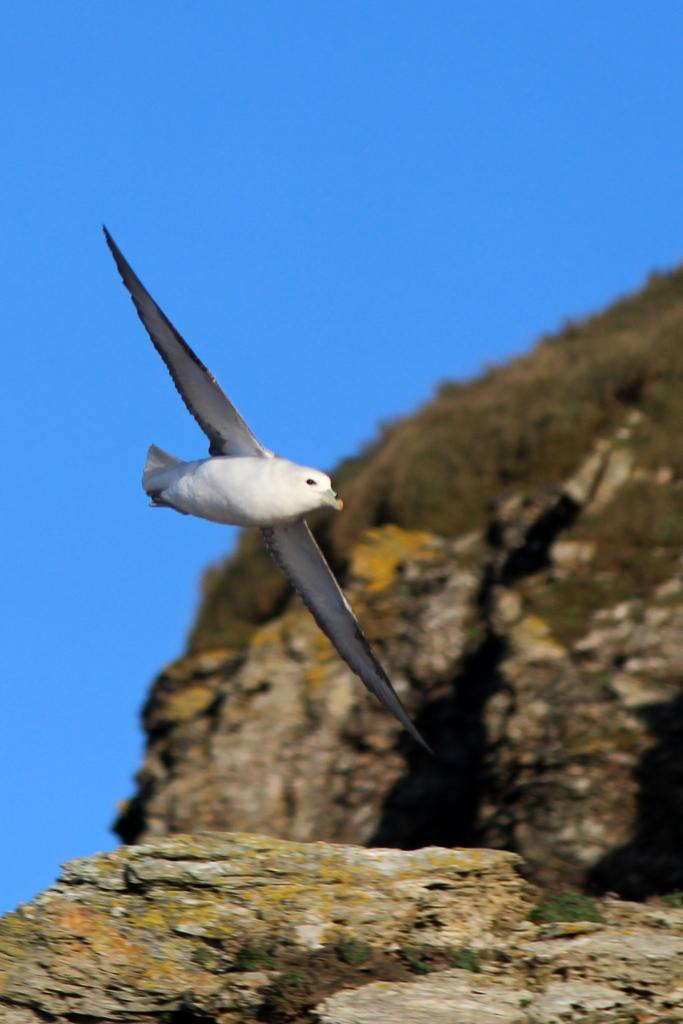What type of animal can be seen in the image? There is a bird in the image. Where is the bird located in the image? The bird is in the air. Can you describe the color of the bird? The bird has white and ash color. What can be seen in the background of the image? There is a mountain and a blue sky in the background of the image. What type of notebook is the bird holding in the image? There is no notebook present in the image; it features a bird in the air with white and ash color. Is there a box visible in the image? There is no box present in the image. 